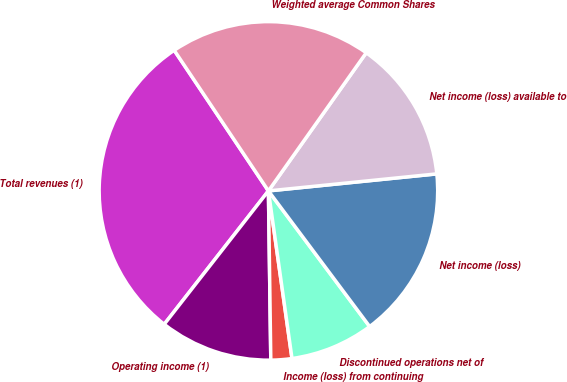Convert chart to OTSL. <chart><loc_0><loc_0><loc_500><loc_500><pie_chart><fcel>Total revenues (1)<fcel>Operating income (1)<fcel>Income (loss) from continuing<fcel>Discontinued operations net of<fcel>Net income (loss)<fcel>Net income (loss) available to<fcel>Weighted average Common Shares<nl><fcel>30.05%<fcel>10.78%<fcel>2.0%<fcel>7.98%<fcel>16.4%<fcel>13.59%<fcel>19.2%<nl></chart> 